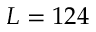<formula> <loc_0><loc_0><loc_500><loc_500>L = 1 2 4</formula> 